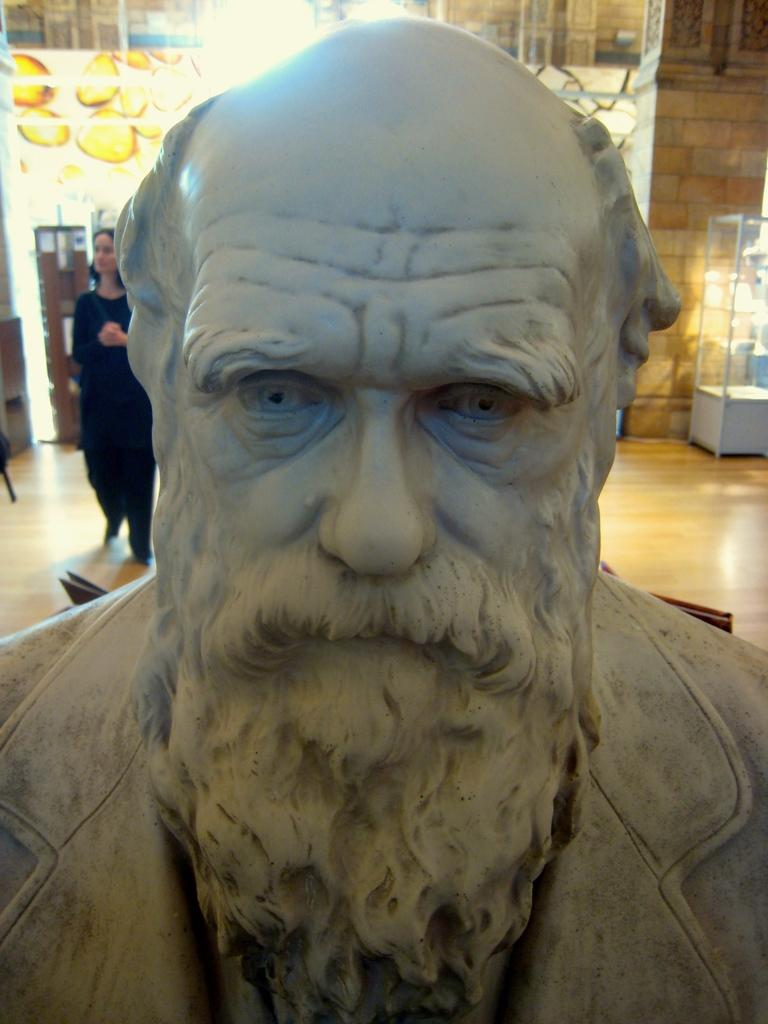What is the main subject in the image? There is a statue in the image. Can you describe anything else in the background of the image? There is a woman standing in the background of the image. What object can be seen on the right side of the image? There is a glass object on the right side of the image. What decision does the eye make in the image? There is no eye present in the image, so no decision can be made. 